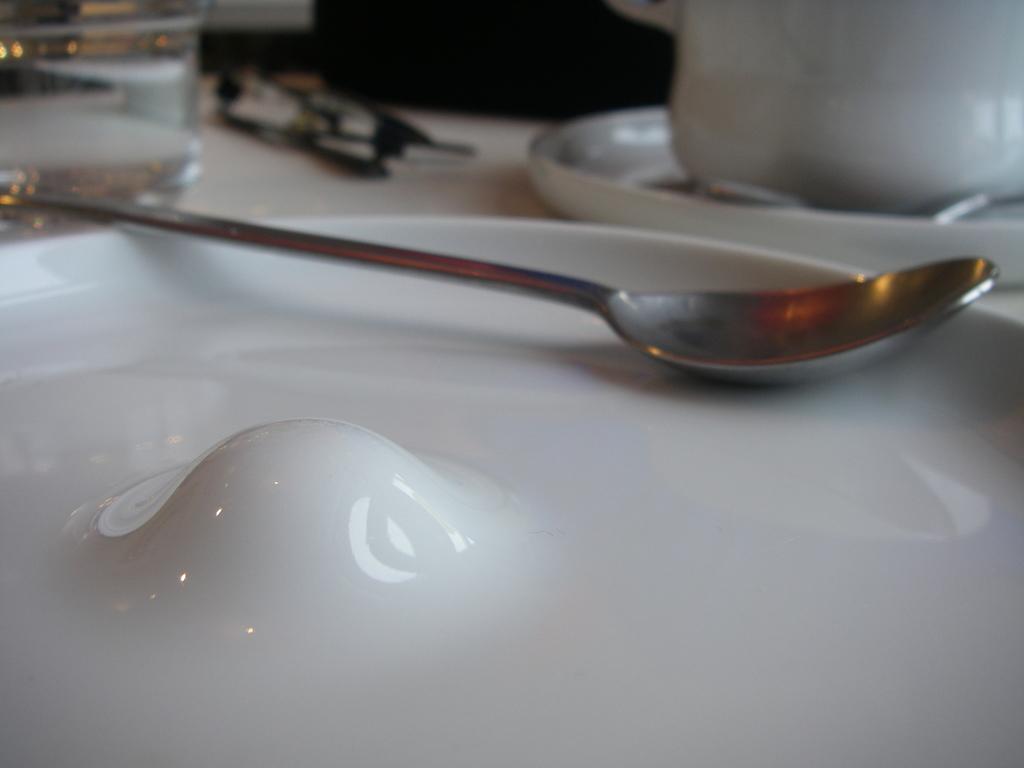Could you give a brief overview of what you see in this image? In this image we can see a plate. On the plate there is a spoon. Near to that we can see a saucer and cup. On the left side there is a glass. And there is an object in the background. 